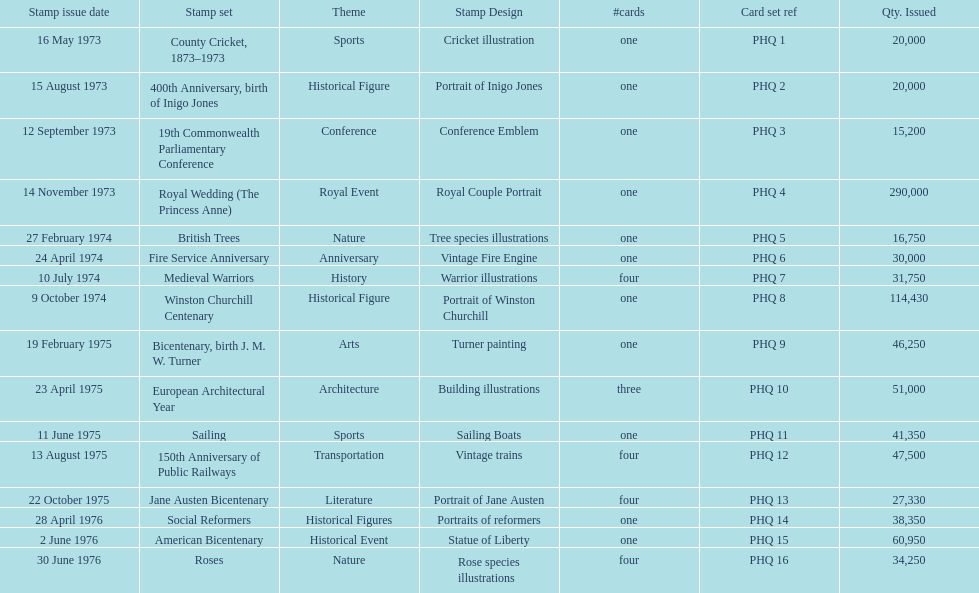Which stamp set had only three cards in the set? European Architectural Year. 